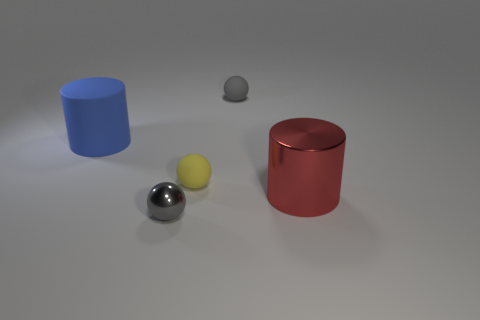Do the tiny shiny ball and the matte thing that is on the right side of the yellow rubber ball have the same color?
Offer a terse response. Yes. Are there fewer red objects to the right of the large red shiny cylinder than small green shiny cylinders?
Offer a terse response. No. How many rubber spheres are there?
Offer a very short reply. 2. What shape is the rubber object that is behind the cylinder that is behind the red object?
Keep it short and to the point. Sphere. What number of shiny objects are on the right side of the yellow matte sphere?
Your answer should be very brief. 1. Does the tiny yellow object have the same material as the large object to the left of the red cylinder?
Make the answer very short. Yes. Is there another cylinder that has the same size as the red cylinder?
Ensure brevity in your answer.  Yes. Are there the same number of blue matte cylinders that are behind the large matte thing and tiny metal cylinders?
Your answer should be compact. Yes. How big is the metal cylinder?
Provide a short and direct response. Large. There is a big cylinder that is behind the metal cylinder; how many large objects are in front of it?
Provide a succinct answer. 1. 